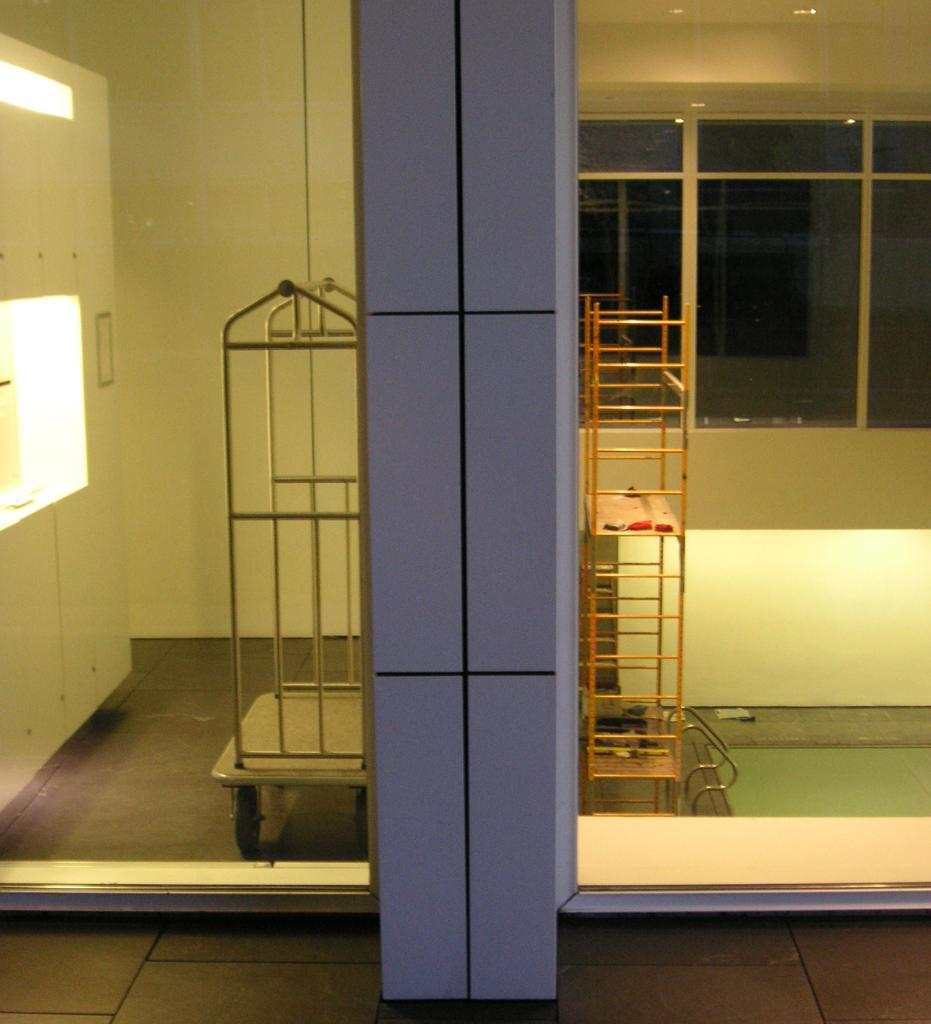How many vehicles are present in the image? There are two vehicles in the image. Where are the vehicles located? The vehicles are on the floor in the image. What can be seen on the wall in the image? There are windows on the wall in the image. What type of furniture is present in the image? There is a closet in the image. What type of badge is the hen wearing in the image? There is no hen or badge present in the image. What thought is the closet having in the image? Closets do not have thoughts, as they are inanimate objects. 